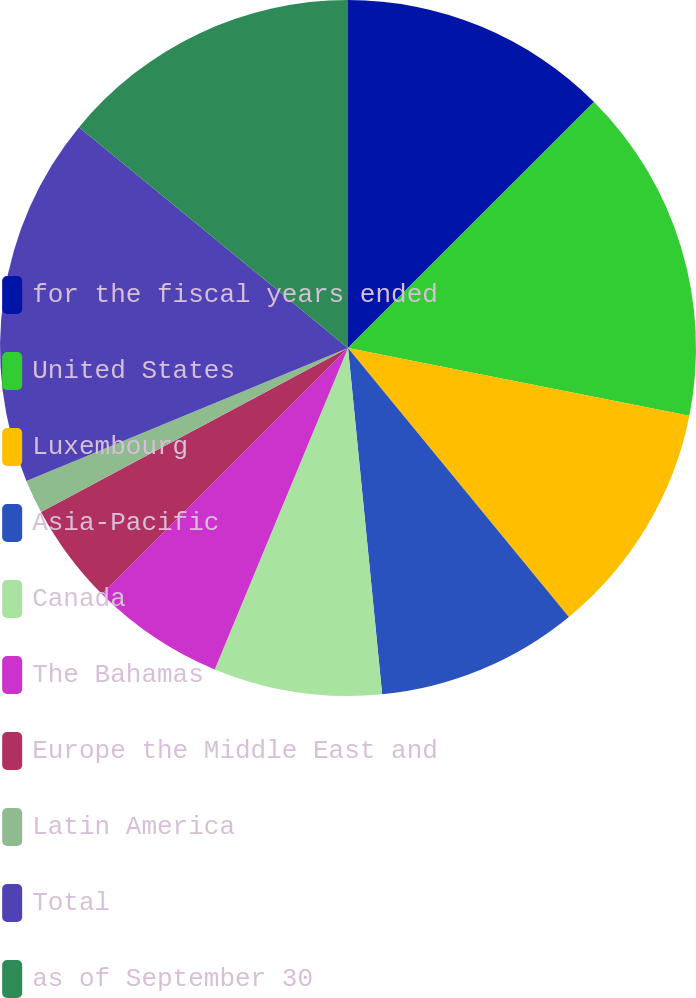<chart> <loc_0><loc_0><loc_500><loc_500><pie_chart><fcel>for the fiscal years ended<fcel>United States<fcel>Luxembourg<fcel>Asia-Pacific<fcel>Canada<fcel>The Bahamas<fcel>Europe the Middle East and<fcel>Latin America<fcel>Total<fcel>as of September 30<nl><fcel>12.5%<fcel>15.62%<fcel>10.94%<fcel>9.38%<fcel>7.82%<fcel>6.25%<fcel>4.69%<fcel>1.57%<fcel>17.18%<fcel>14.06%<nl></chart> 